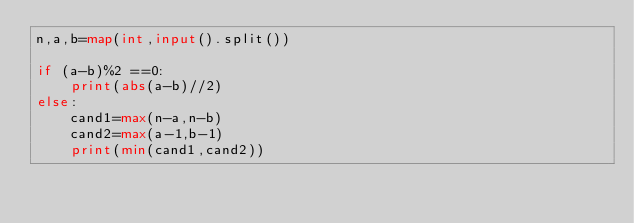<code> <loc_0><loc_0><loc_500><loc_500><_Python_>n,a,b=map(int,input().split())

if (a-b)%2 ==0:
    print(abs(a-b)//2)
else:
    cand1=max(n-a,n-b)
    cand2=max(a-1,b-1)
    print(min(cand1,cand2))</code> 